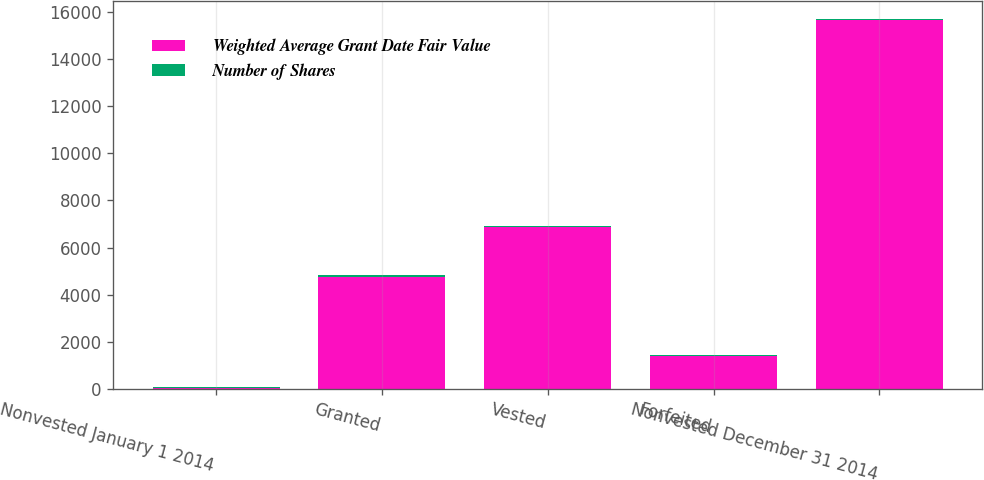Convert chart to OTSL. <chart><loc_0><loc_0><loc_500><loc_500><stacked_bar_chart><ecel><fcel>Nonvested January 1 2014<fcel>Granted<fcel>Vested<fcel>Forfeited<fcel>Nonvested December 31 2014<nl><fcel>Weighted Average Grant Date Fair Value<fcel>58.13<fcel>4776<fcel>6866<fcel>1410<fcel>15634<nl><fcel>Number of Shares<fcel>40.07<fcel>58.13<fcel>36.36<fcel>46.22<fcel>46.66<nl></chart> 